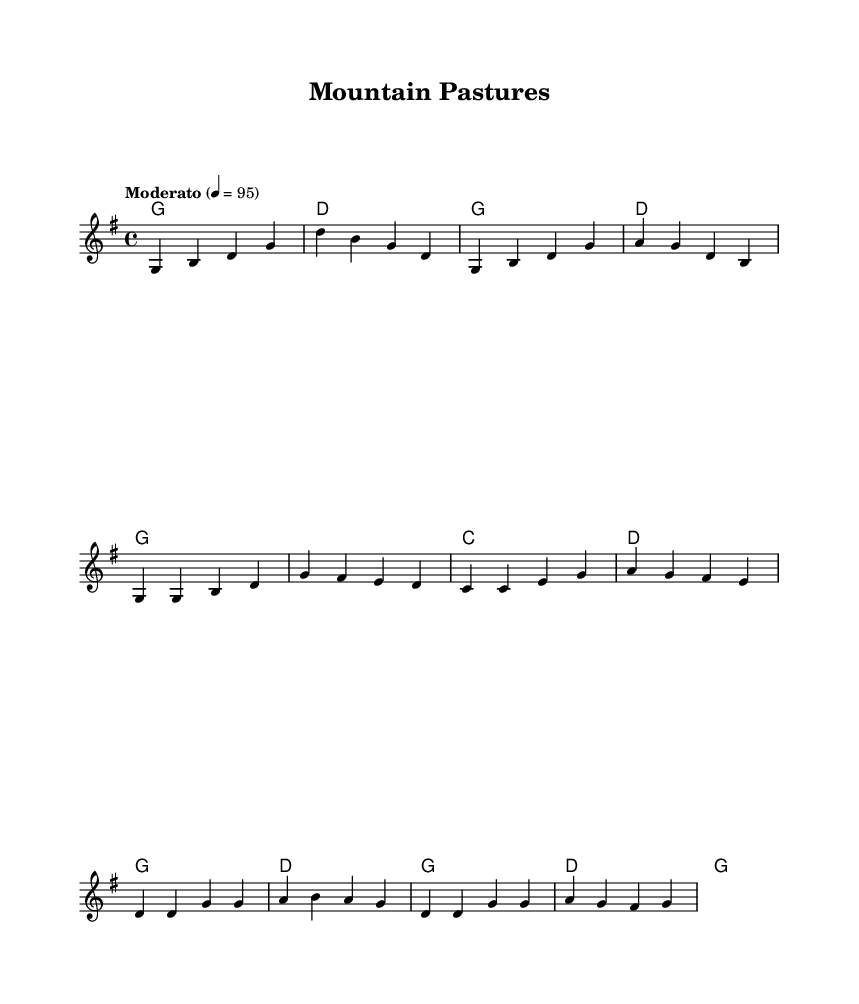What is the key signature of this music? The key signature is G major, which has one sharp (F#).
Answer: G major What is the time signature of this music? The time signature is four four, meaning there are four beats per measure.
Answer: 4/4 What is the tempo marking for this piece? The tempo marking indicates a moderato speed, set at a quarter note equals 95 beats per minute.
Answer: Moderato How many measures are there in the intro section? The intro consists of four measures, as indicated by the grouping of notes before the verse.
Answer: 4 What chords are used in the chorus section? The chorus features the chords G, D, and A, which are indicated in the harmonies written above the staff.
Answer: G, D, A What can you infer about the topic of this folk song based on the title and content? The title "Mountain Pastures" suggests themes related to farming and livestock common in Appalachian folklore, as folk music often celebrates rural life.
Answer: Farming and livestock What is the first note of the melody? The first note in the melody is G, which sets the tone right at the beginning of the piece.
Answer: G 